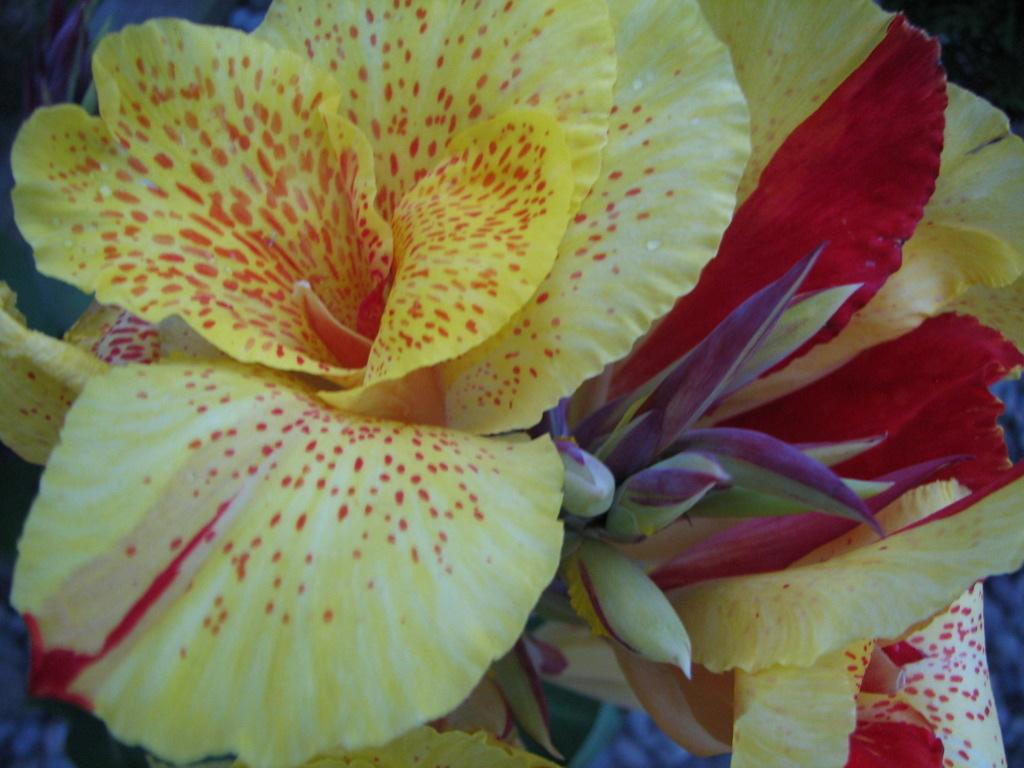What type of image is being shown? The image is a zoomed picture. What can be seen in the foreground of the image? There are flowers and buds in the foreground of the image. Are there any other objects visible in the image? Yes, there are other objects visible in the background of the image. What type of chairs can be seen in the image? There are no chairs present in the image. What force is being applied to the flowers in the image? There is no force being applied to the flowers in the image; they are stationary in the foreground. 